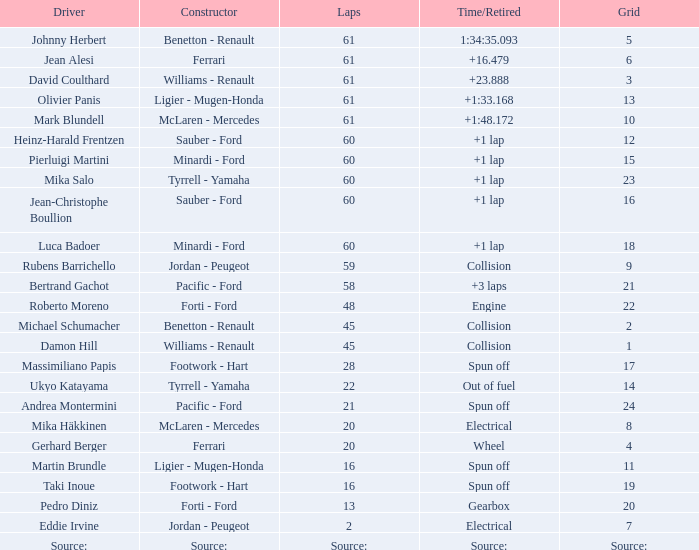What is the total count of laps completed by roberto moreno? 48.0. 